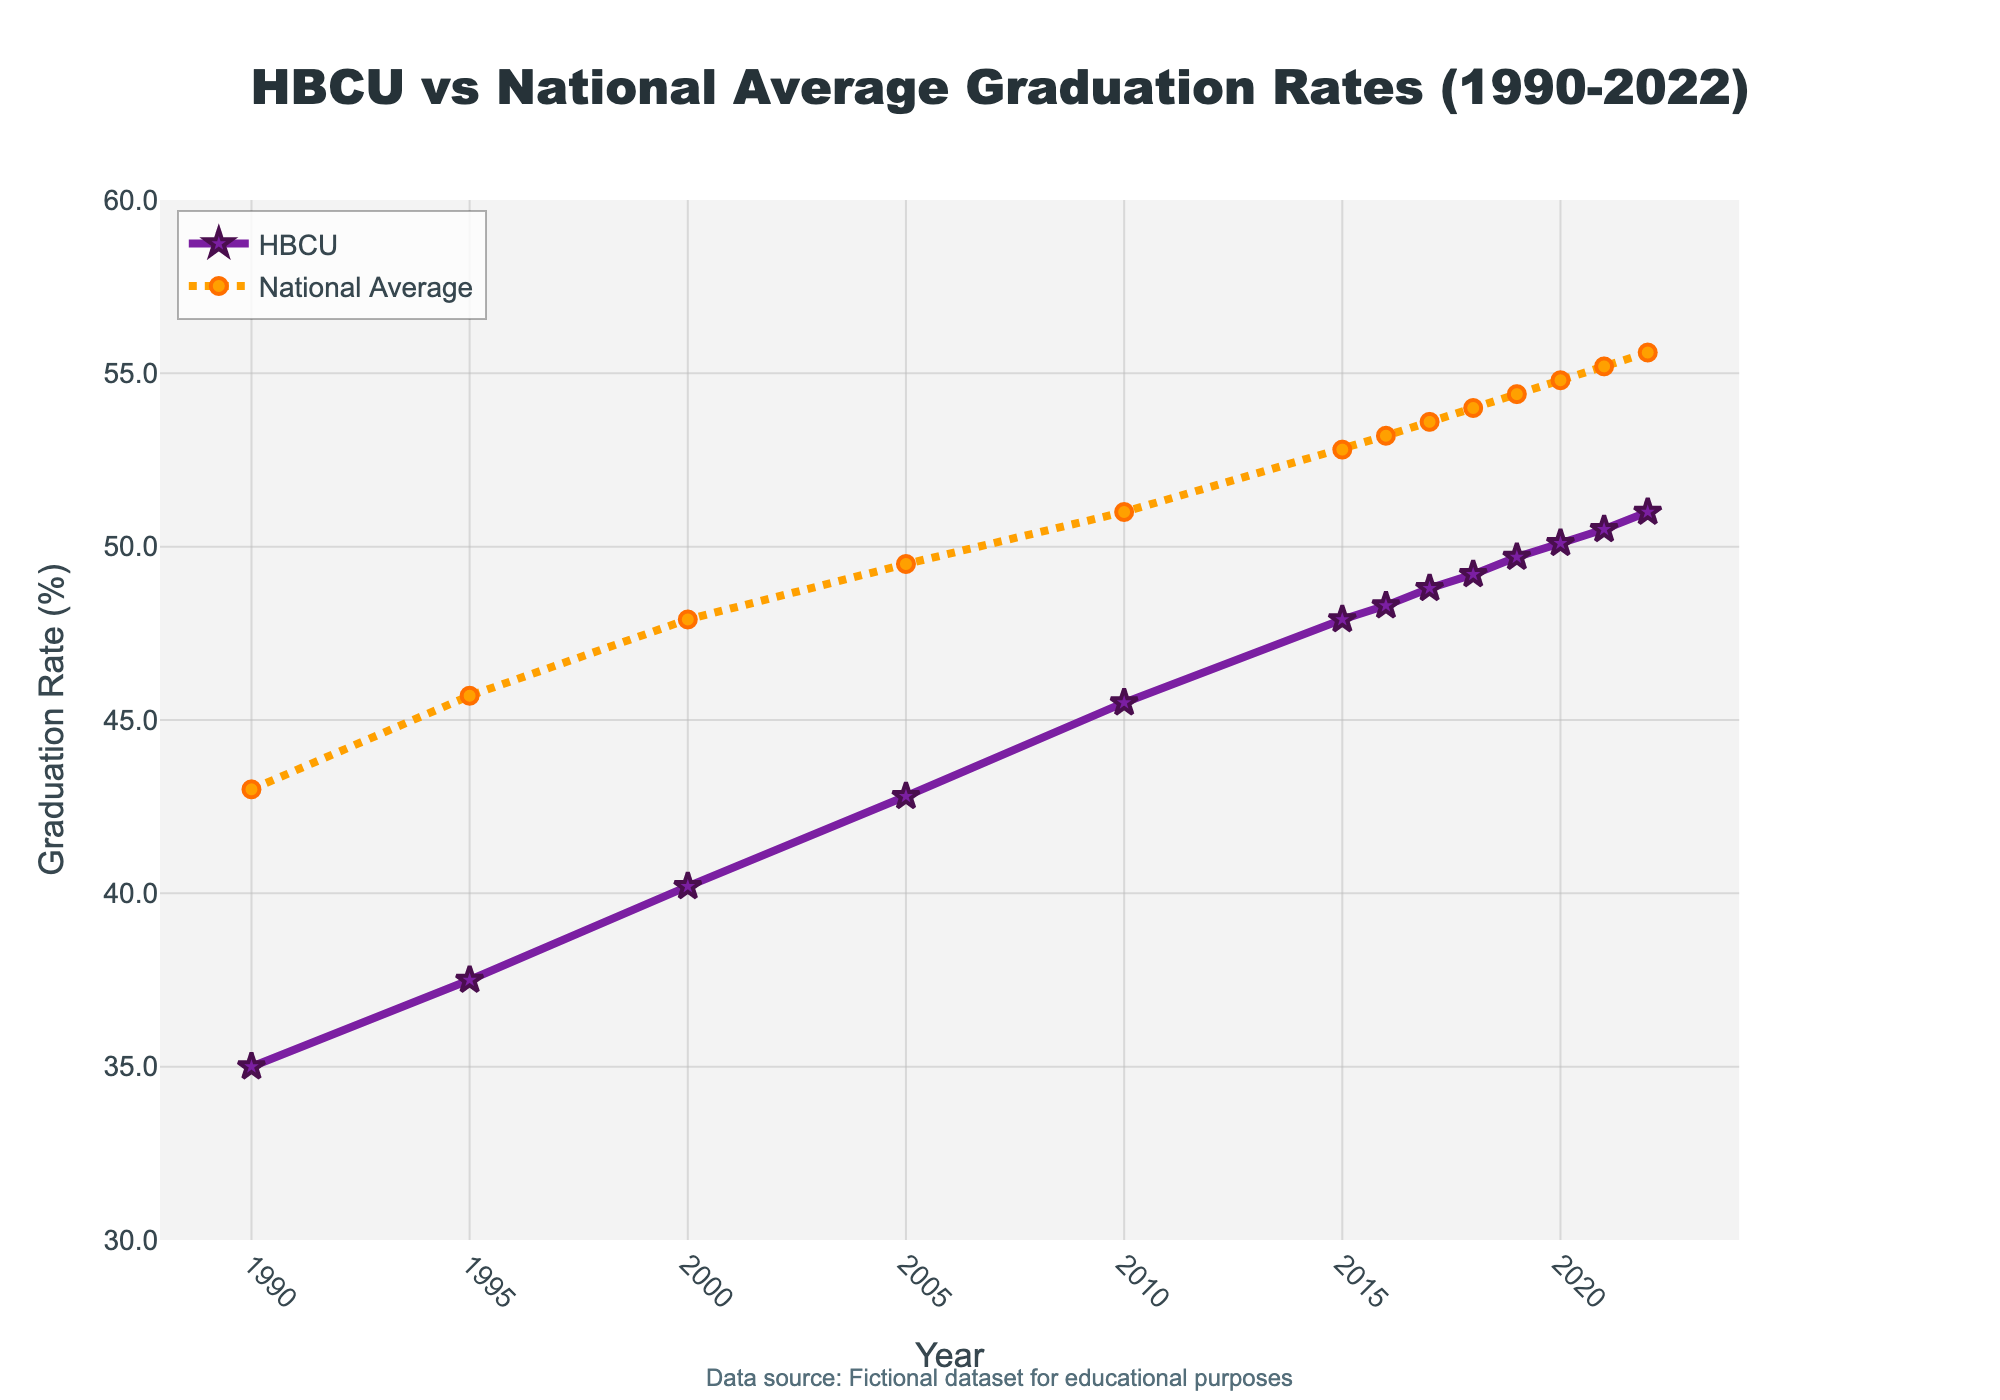How has the graduation rate for HBCUs changed from 1990 to 2022? From the chart, we see that the HBCU graduation rate increased from 35.0% in 1990 to 51.0% in 2022. This change can be calculated as 51.0 - 35.0 = 16 percentage points.
Answer: 16 percentage points In which year did the graduation rate for HBCUs cross 50%? The figure shows that the HBCU graduation rate crossed 50% in the year 2020 where the rate was 50.1%.
Answer: 2020 By how much did the national average graduation rate exceed the HBCU graduation rate in 1995? In 1995, the national average graduation rate was 45.7%, and the HBCU graduation rate was 37.5%. The difference is calculated as 45.7 - 37.5 = 8.2 percentage points.
Answer: 8.2 percentage points What is the average HBCU graduation rate over the years 1990 to 2022? To find the average, add all the given HBCU graduation rates and divide by the number of years. (35.0 + 37.5 + 40.2 + 42.8 + 45.5 + 47.9 + 48.3 + 48.8 + 49.2 + 49.7 + 50.1 + 50.5 + 51.0) / 13 = 45.19%.
Answer: 45.19% Compare the trends of HBCU and national average graduation rates from 2000 to 2010. From 2000 to 2010, both the HBCU and national average graduation rates increased. The HBCU rate went from 40.2% to 45.5% (an increase of 5.3 percentage points), while the national average went from 47.9% to 51.0% (an increase of 3.1 percentage points).
Answer: HBCU: +5.3 points, National Average: +3.1 points What year had the smallest difference between HBCU and national average graduation rates? By examining the chart, the smallest difference appears to be in 2022 where the HBCU rate is 51.0% and the national average is 55.6%, giving a difference of 4.6 percentage points.
Answer: 2022 What visual elements differentiate the two lines representing HBCU and national average graduation rates? The HBCU line is represented by a solid purple line with star markers, while the national average line is represented by an orange dotted line with circle markers.
Answer: Line and marker styles How did the rate of increase in graduation rates for HBCUs compare to the national average from 2005 to 2015? HBCU graduation rates increased from 42.8% in 2005 to 47.9% in 2015, a 5.1 percentage point increase. National average rates increased from 49.5% in 2005 to 52.8% in 2015, a 3.3 percentage point increase.
Answer: HBCU: +5.1 points, National Average: +3.3 points What is the difference in graduation rates between 1990 and 2022 for both HBCUs and the national average? For HBCUs, the rate increased from 35.0% to 51.0%, a difference of 16 percentage points. For the national average, the rate increased from 43.0% to 55.6%, a difference of 12.6 percentage points.
Answer: HBCU: +16 points, National Average: +12.6 points 